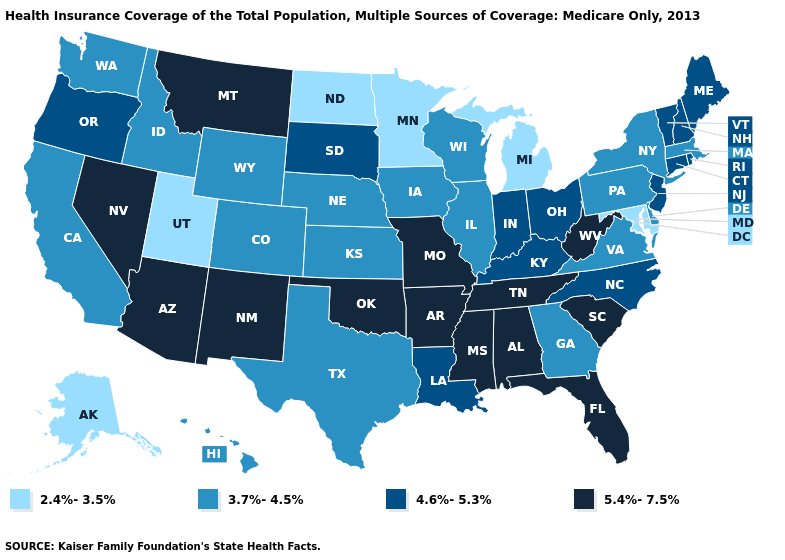Among the states that border Illinois , does Wisconsin have the lowest value?
Short answer required. Yes. Name the states that have a value in the range 2.4%-3.5%?
Answer briefly. Alaska, Maryland, Michigan, Minnesota, North Dakota, Utah. What is the highest value in states that border California?
Quick response, please. 5.4%-7.5%. Does California have the lowest value in the USA?
Be succinct. No. Which states hav the highest value in the Northeast?
Short answer required. Connecticut, Maine, New Hampshire, New Jersey, Rhode Island, Vermont. What is the lowest value in states that border Connecticut?
Answer briefly. 3.7%-4.5%. Is the legend a continuous bar?
Give a very brief answer. No. Which states have the lowest value in the USA?
Answer briefly. Alaska, Maryland, Michigan, Minnesota, North Dakota, Utah. What is the lowest value in states that border Minnesota?
Concise answer only. 2.4%-3.5%. Does Idaho have the highest value in the USA?
Be succinct. No. Does Wisconsin have a higher value than Rhode Island?
Give a very brief answer. No. What is the value of Tennessee?
Be succinct. 5.4%-7.5%. What is the highest value in the Northeast ?
Write a very short answer. 4.6%-5.3%. Does Oregon have a lower value than North Dakota?
Write a very short answer. No. What is the lowest value in the USA?
Short answer required. 2.4%-3.5%. 